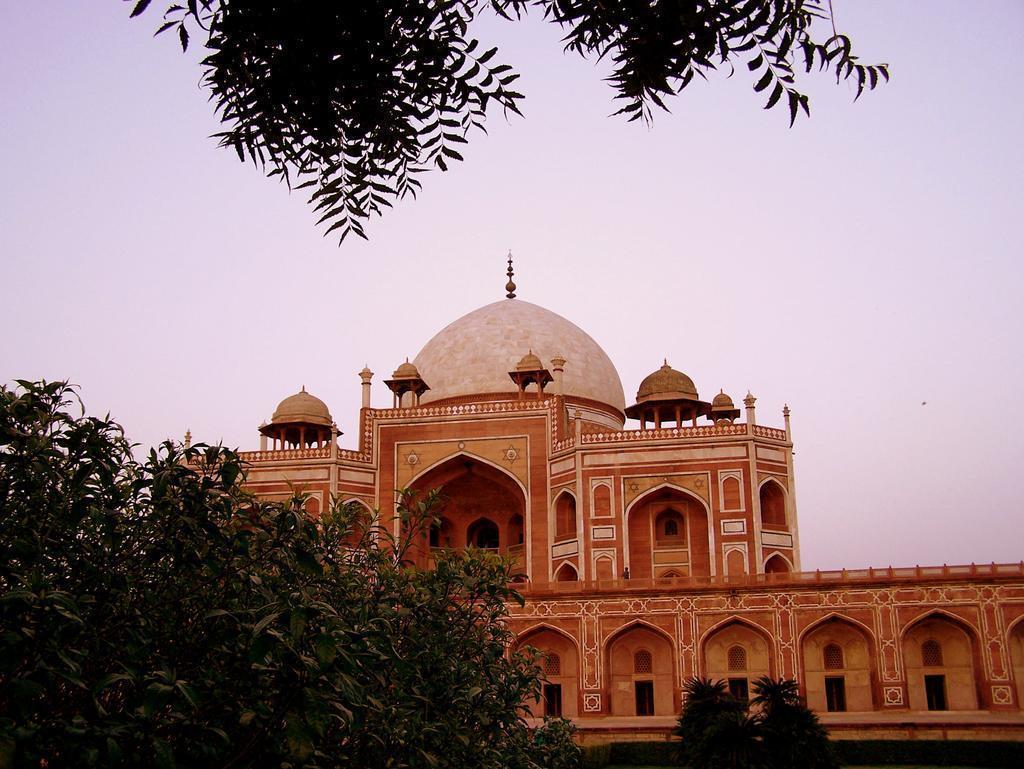Please provide a concise description of this image. In this picture there is red fort in the center of the image and there are plants at the top and bottom side of the image. 